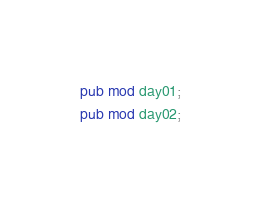Convert code to text. <code><loc_0><loc_0><loc_500><loc_500><_Rust_>pub mod day01;
pub mod day02;
</code> 